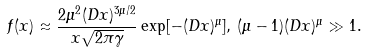<formula> <loc_0><loc_0><loc_500><loc_500>f ( x ) \approx \frac { 2 \mu ^ { 2 } ( D x ) ^ { 3 \mu / 2 } } { x \sqrt { 2 \pi \gamma } } \exp [ - ( D x ) ^ { \mu } ] , \, ( \mu - 1 ) ( D x ) ^ { \mu } \gg 1 .</formula> 